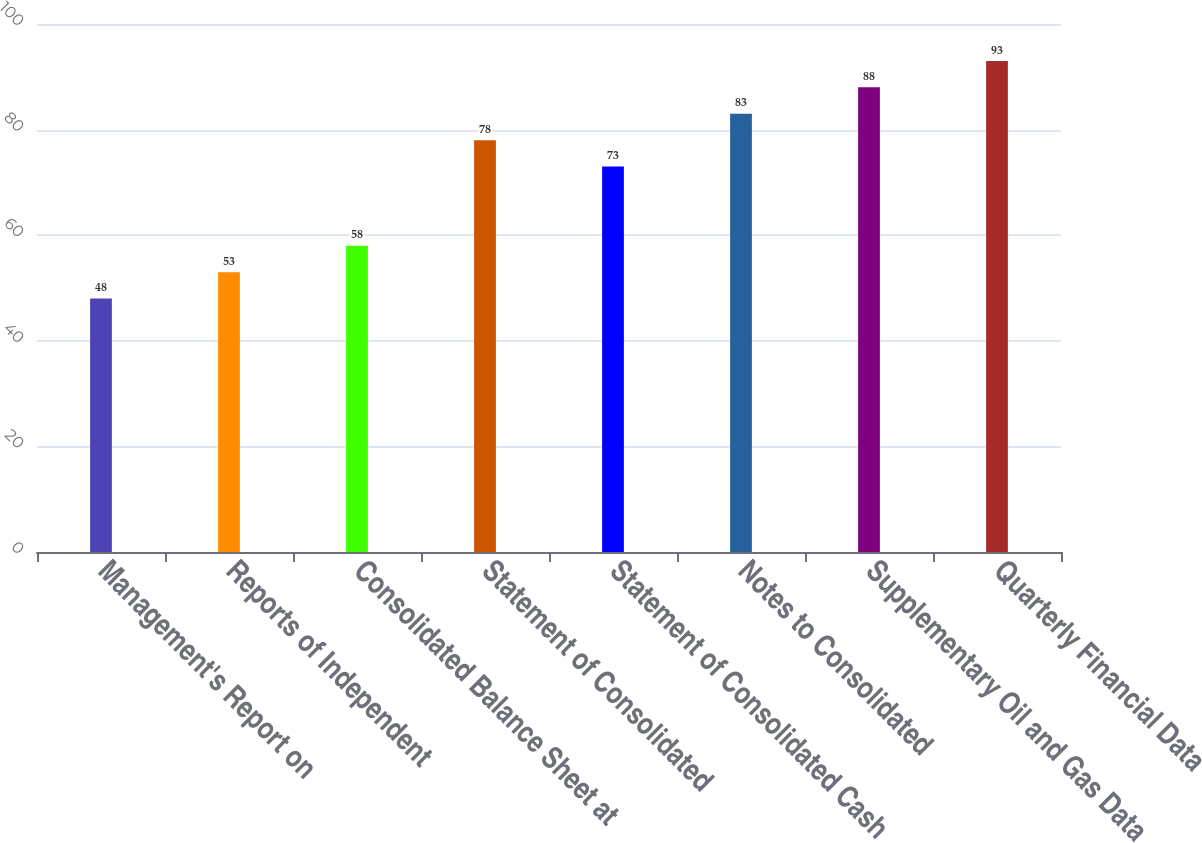<chart> <loc_0><loc_0><loc_500><loc_500><bar_chart><fcel>Management's Report on<fcel>Reports of Independent<fcel>Consolidated Balance Sheet at<fcel>Statement of Consolidated<fcel>Statement of Consolidated Cash<fcel>Notes to Consolidated<fcel>Supplementary Oil and Gas Data<fcel>Quarterly Financial Data<nl><fcel>48<fcel>53<fcel>58<fcel>78<fcel>73<fcel>83<fcel>88<fcel>93<nl></chart> 